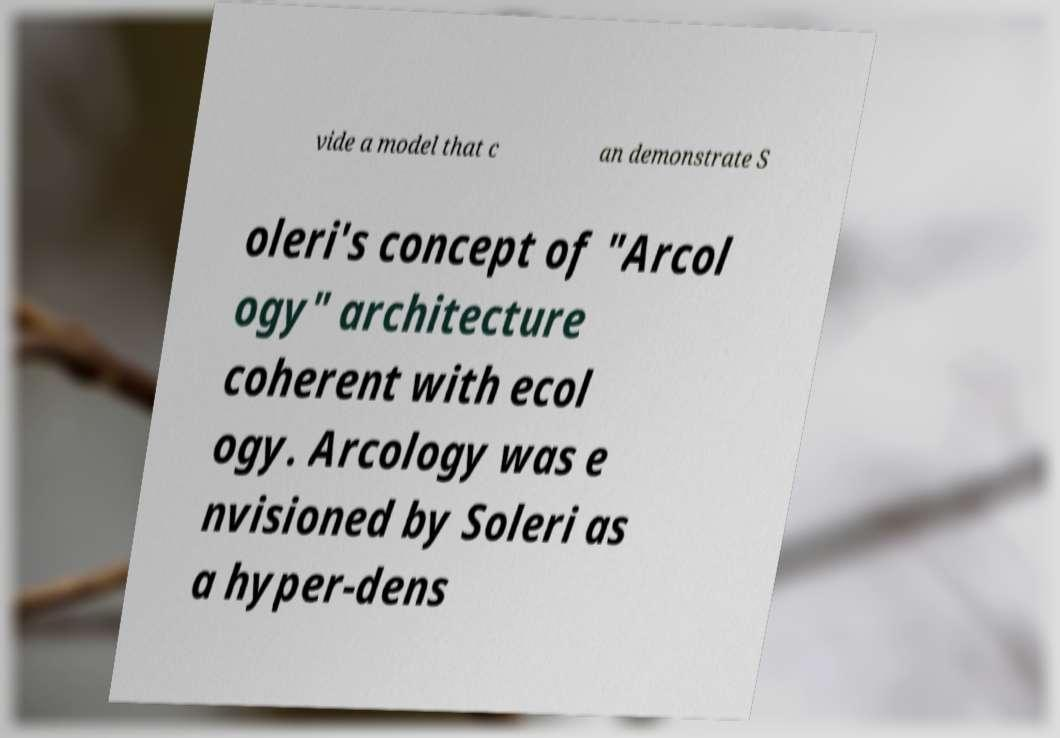What messages or text are displayed in this image? I need them in a readable, typed format. vide a model that c an demonstrate S oleri's concept of "Arcol ogy" architecture coherent with ecol ogy. Arcology was e nvisioned by Soleri as a hyper-dens 